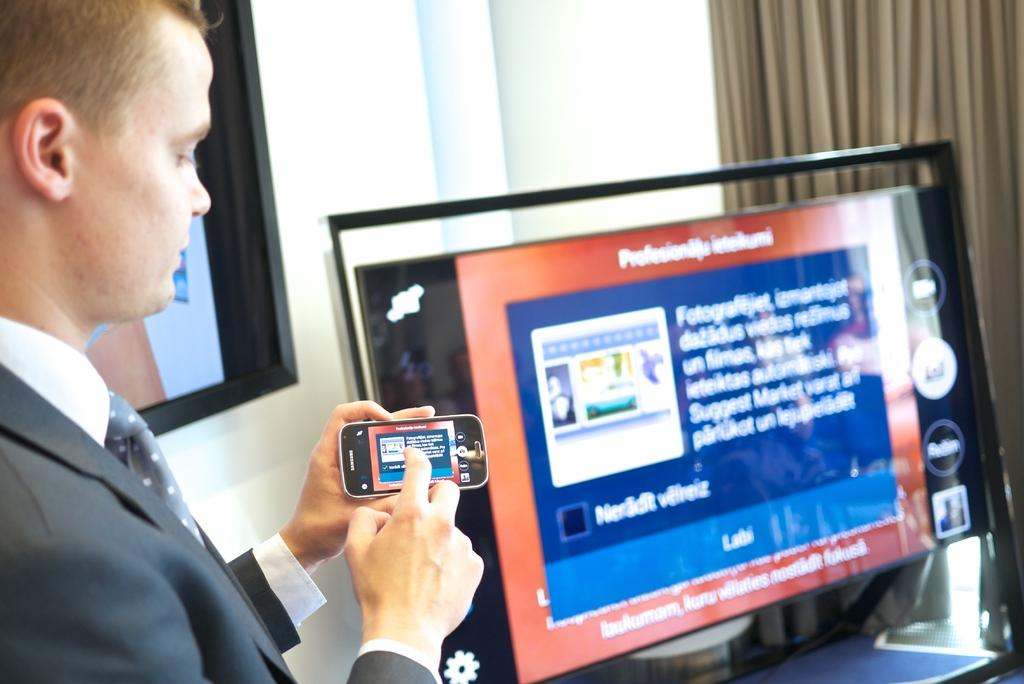Who is the main subject in the image? There is a man in the image. Where is the man located in the image? The man is on the left side of the image. What is the man doing in the image? The man is showing something on his mobile. What type of detail can be seen on the man's lunch in the image? There is no mention of lunch in the image, so it is not possible to answer a question about the details of the man's lunch. 